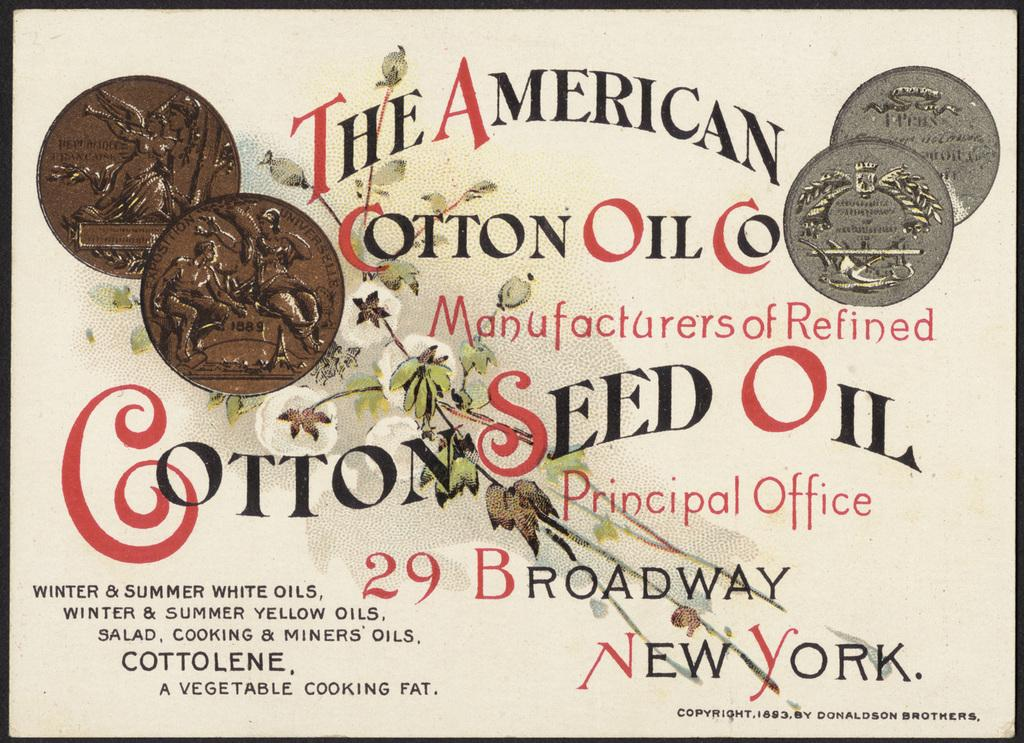<image>
Provide a brief description of the given image. An advertisement shows the location of the headquarters for The American Cotton Oil Co. 